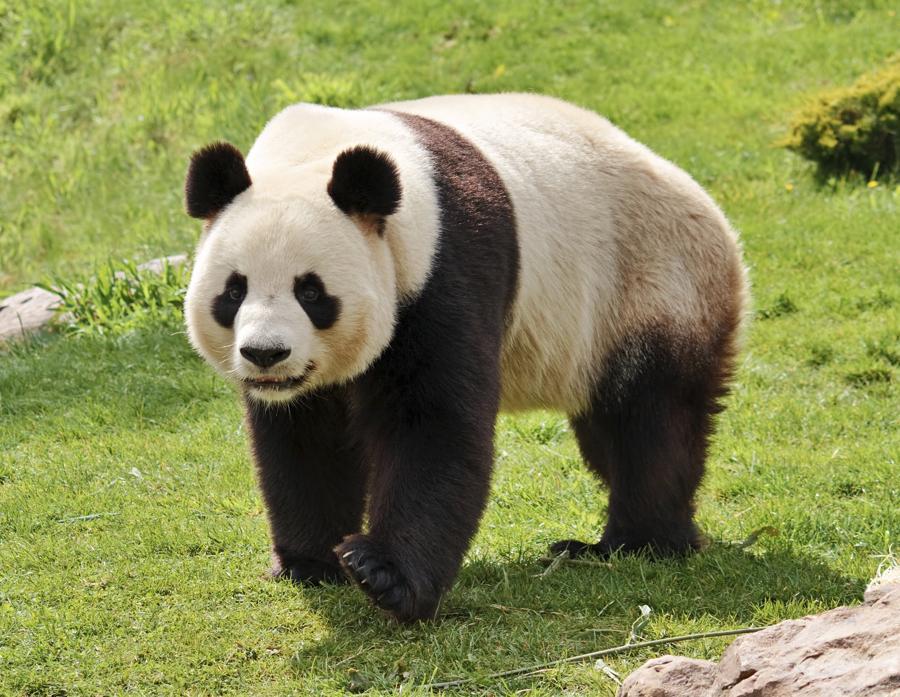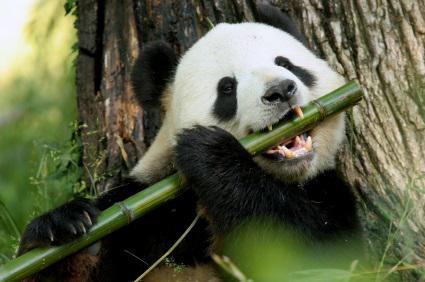The first image is the image on the left, the second image is the image on the right. Assess this claim about the two images: "The panda on the left is in a tree.". Correct or not? Answer yes or no. No. The first image is the image on the left, the second image is the image on the right. Given the left and right images, does the statement "An image includes a panda at least partly lying on its back on green ground." hold true? Answer yes or no. No. 